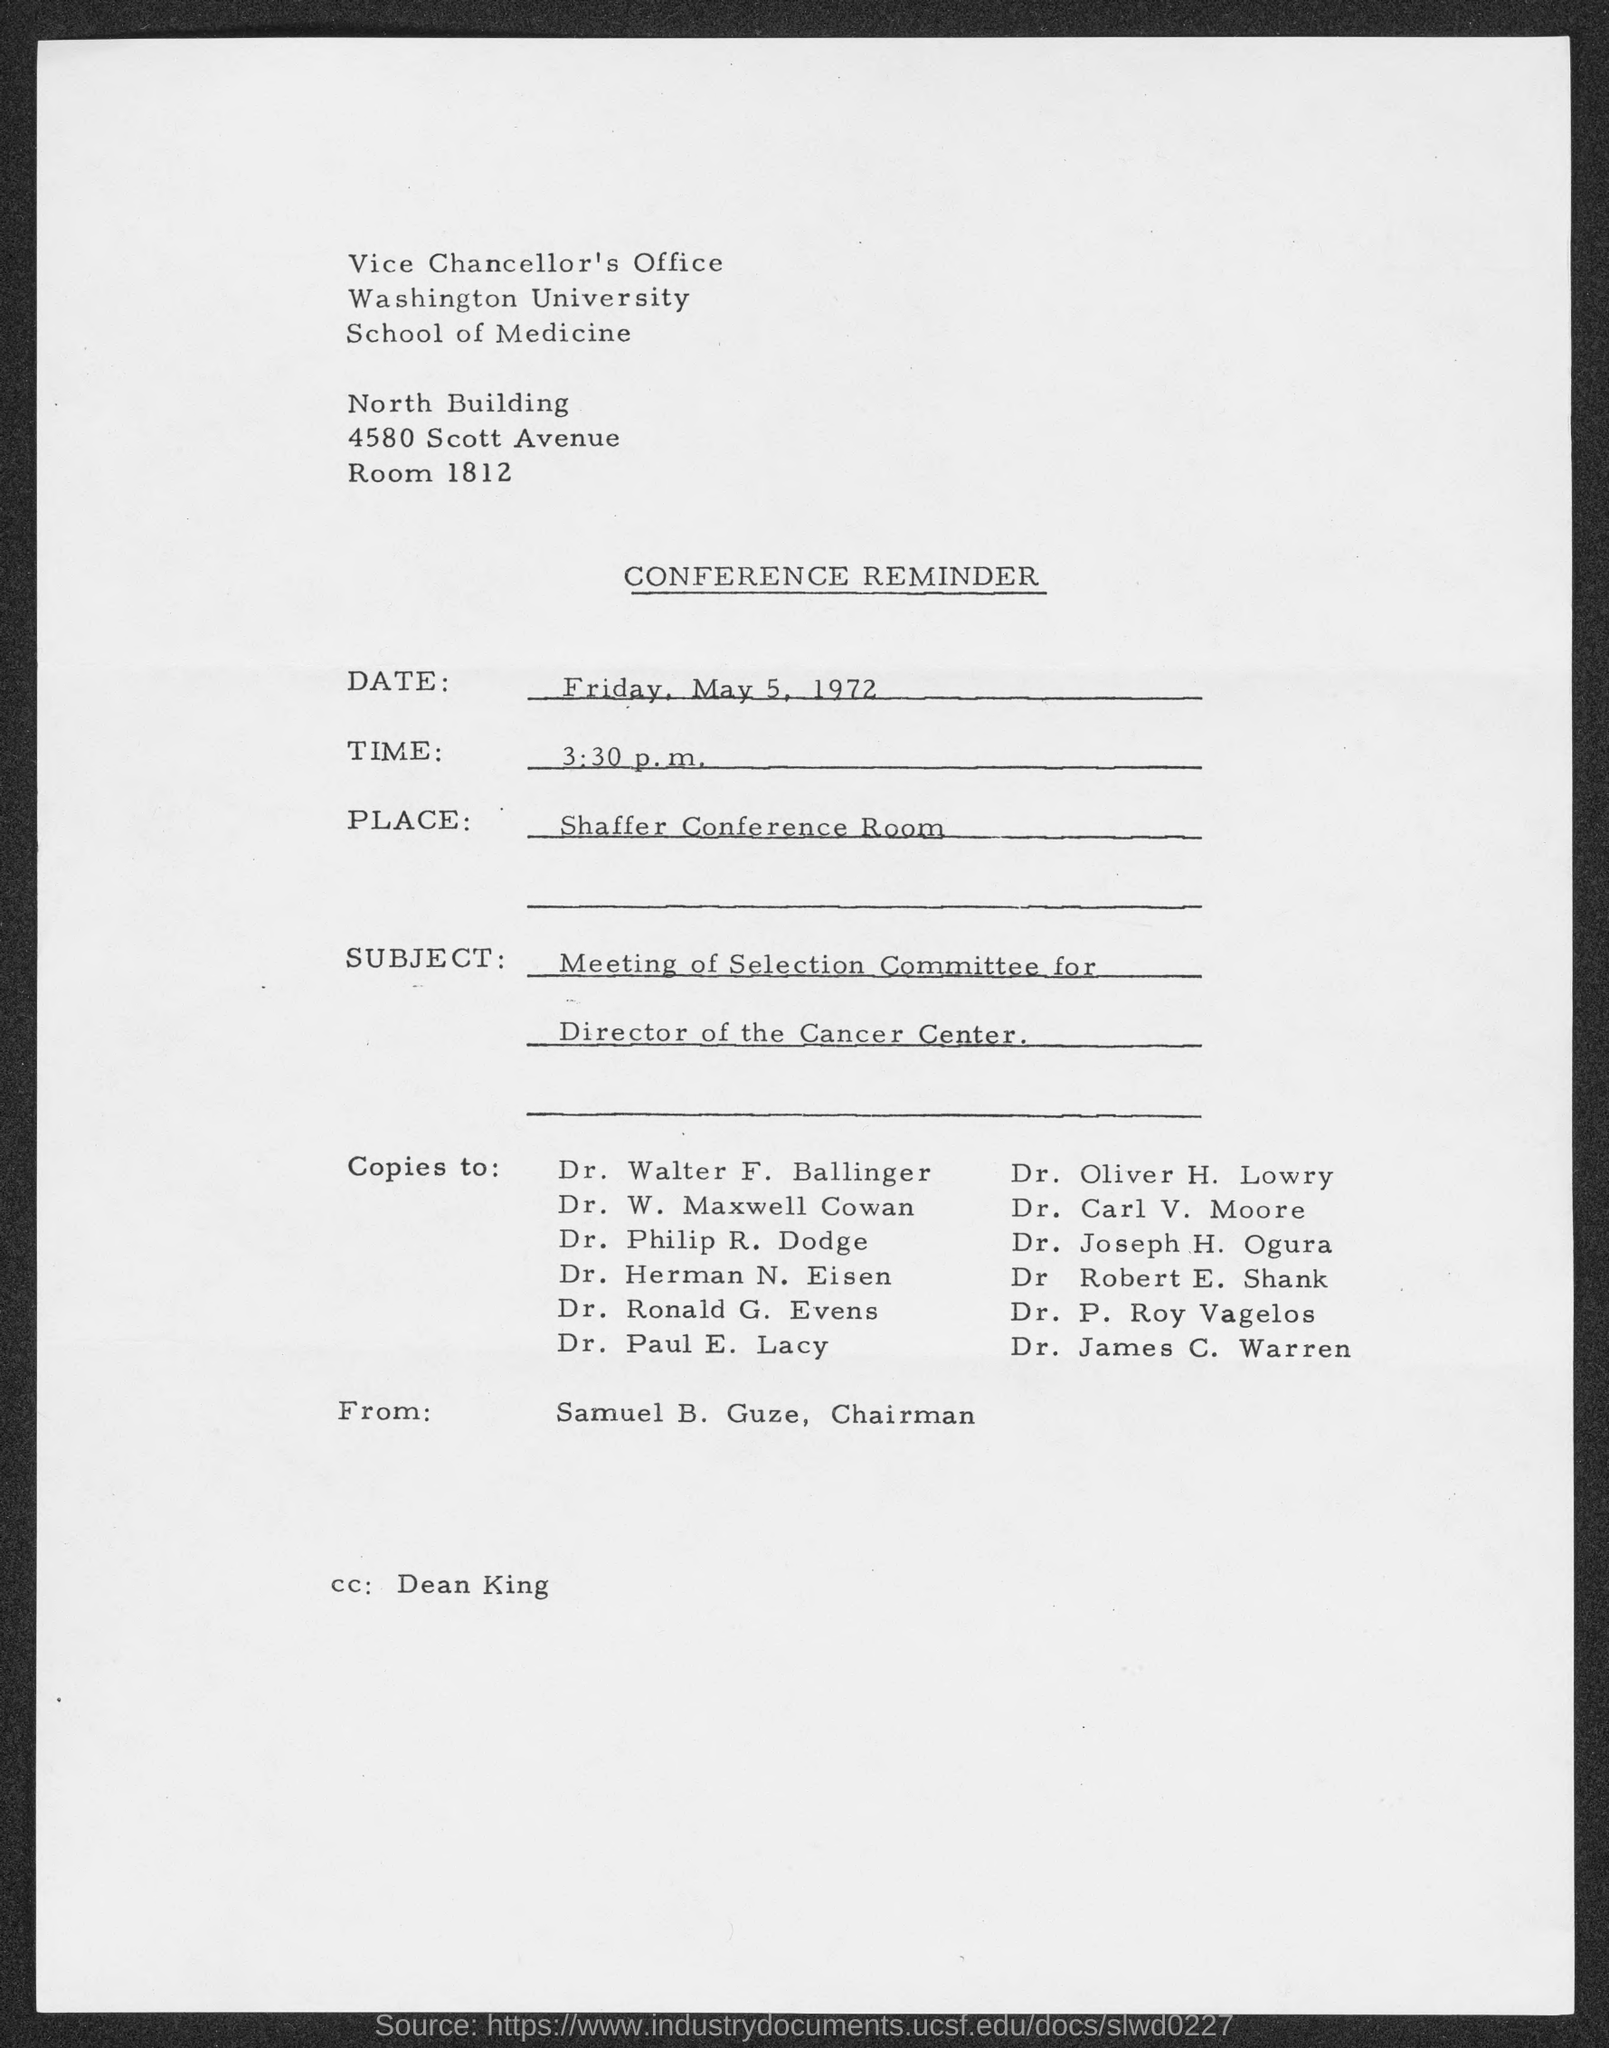What type of document this ?
Ensure brevity in your answer.  Conference Reminder. Who is the memorandum from ?
Keep it short and to the point. Samuel B. Guze. Who is the "CC" Address ?
Your response must be concise. Dean King. 